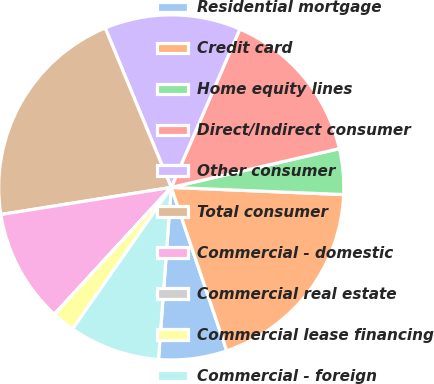Convert chart to OTSL. <chart><loc_0><loc_0><loc_500><loc_500><pie_chart><fcel>Residential mortgage<fcel>Credit card<fcel>Home equity lines<fcel>Direct/Indirect consumer<fcel>Other consumer<fcel>Total consumer<fcel>Commercial - domestic<fcel>Commercial real estate<fcel>Commercial lease financing<fcel>Commercial - foreign<nl><fcel>6.39%<fcel>19.13%<fcel>4.27%<fcel>14.89%<fcel>12.76%<fcel>21.26%<fcel>10.64%<fcel>0.02%<fcel>2.14%<fcel>8.51%<nl></chart> 